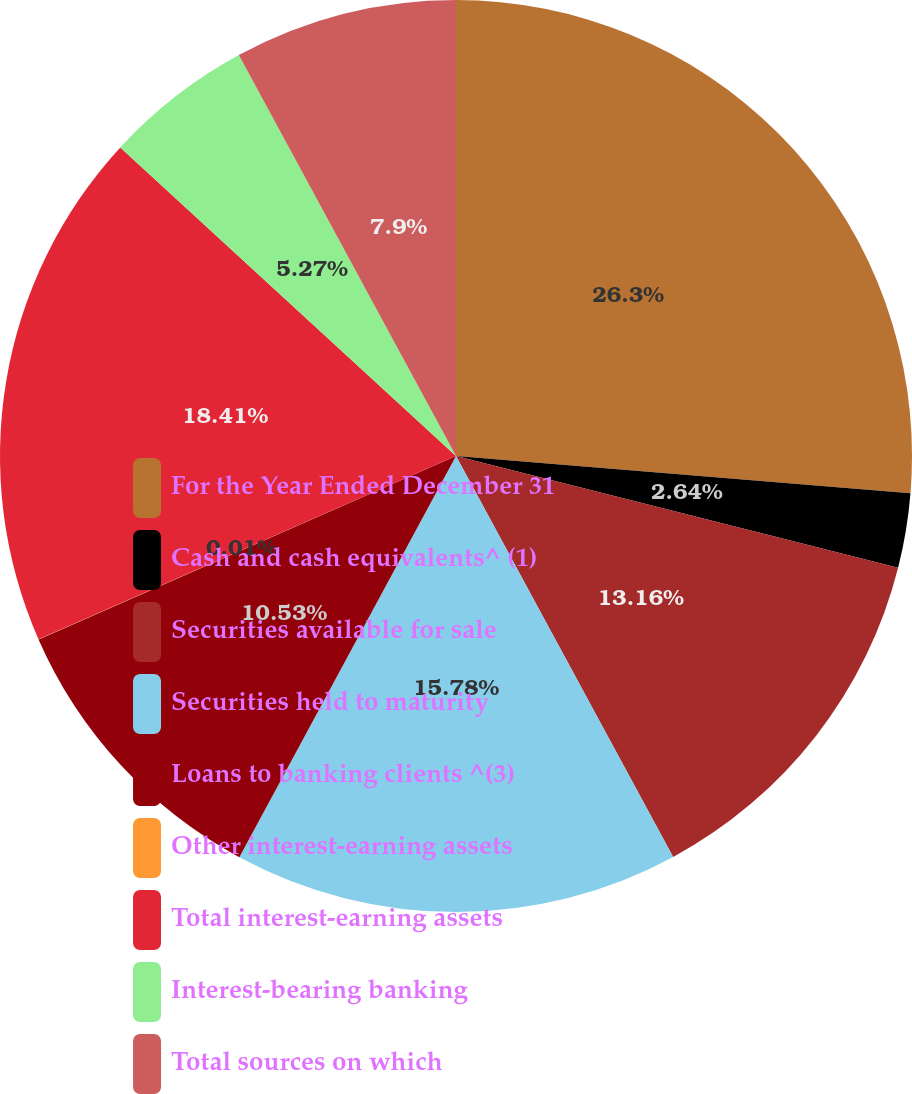Convert chart. <chart><loc_0><loc_0><loc_500><loc_500><pie_chart><fcel>For the Year Ended December 31<fcel>Cash and cash equivalents^ (1)<fcel>Securities available for sale<fcel>Securities held to maturity<fcel>Loans to banking clients ^(3)<fcel>Other interest-earning assets<fcel>Total interest-earning assets<fcel>Interest-bearing banking<fcel>Total sources on which<nl><fcel>26.3%<fcel>2.64%<fcel>13.16%<fcel>15.78%<fcel>10.53%<fcel>0.01%<fcel>18.41%<fcel>5.27%<fcel>7.9%<nl></chart> 